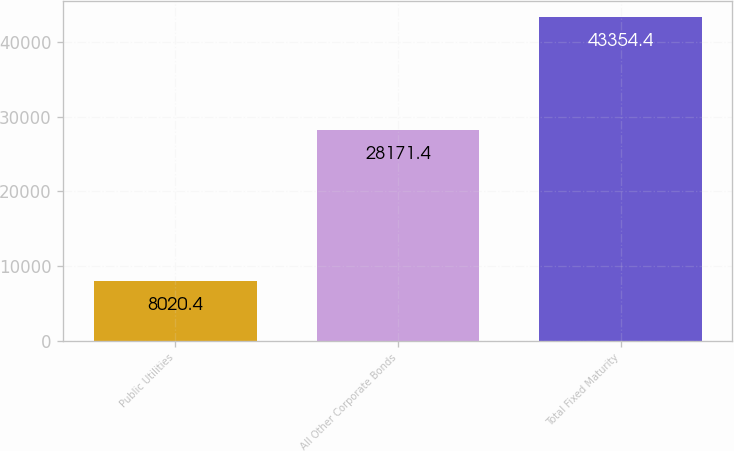Convert chart to OTSL. <chart><loc_0><loc_0><loc_500><loc_500><bar_chart><fcel>Public Utilities<fcel>All Other Corporate Bonds<fcel>Total Fixed Maturity<nl><fcel>8020.4<fcel>28171.4<fcel>43354.4<nl></chart> 